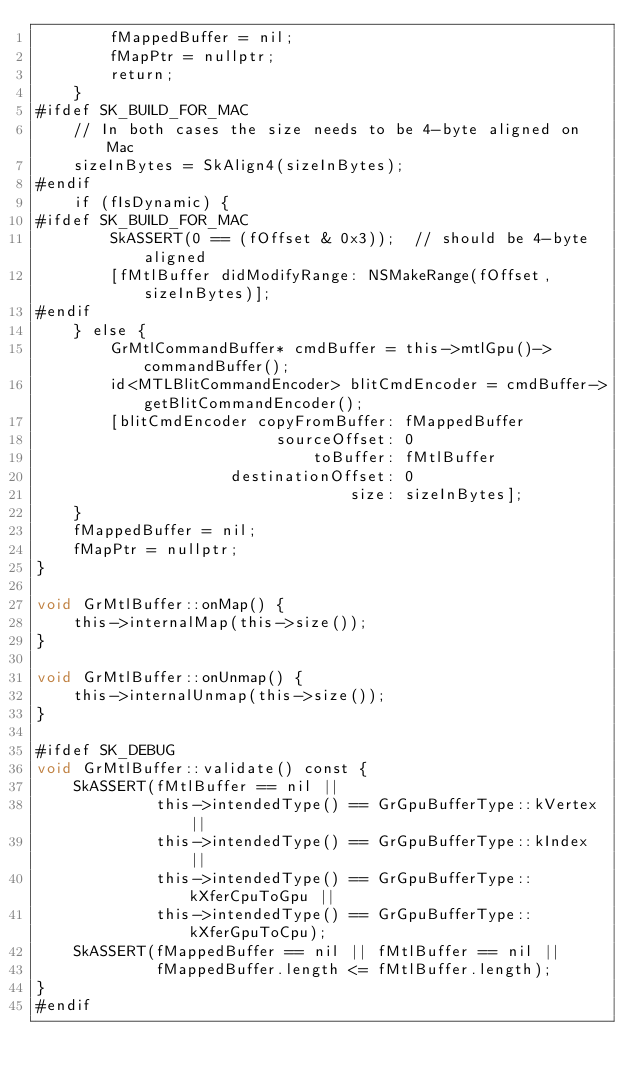<code> <loc_0><loc_0><loc_500><loc_500><_ObjectiveC_>        fMappedBuffer = nil;
        fMapPtr = nullptr;
        return;
    }
#ifdef SK_BUILD_FOR_MAC
    // In both cases the size needs to be 4-byte aligned on Mac
    sizeInBytes = SkAlign4(sizeInBytes);
#endif
    if (fIsDynamic) {
#ifdef SK_BUILD_FOR_MAC
        SkASSERT(0 == (fOffset & 0x3));  // should be 4-byte aligned
        [fMtlBuffer didModifyRange: NSMakeRange(fOffset, sizeInBytes)];
#endif
    } else {
        GrMtlCommandBuffer* cmdBuffer = this->mtlGpu()->commandBuffer();
        id<MTLBlitCommandEncoder> blitCmdEncoder = cmdBuffer->getBlitCommandEncoder();
        [blitCmdEncoder copyFromBuffer: fMappedBuffer
                          sourceOffset: 0
                              toBuffer: fMtlBuffer
                     destinationOffset: 0
                                  size: sizeInBytes];
    }
    fMappedBuffer = nil;
    fMapPtr = nullptr;
}

void GrMtlBuffer::onMap() {
    this->internalMap(this->size());
}

void GrMtlBuffer::onUnmap() {
    this->internalUnmap(this->size());
}

#ifdef SK_DEBUG
void GrMtlBuffer::validate() const {
    SkASSERT(fMtlBuffer == nil ||
             this->intendedType() == GrGpuBufferType::kVertex ||
             this->intendedType() == GrGpuBufferType::kIndex ||
             this->intendedType() == GrGpuBufferType::kXferCpuToGpu ||
             this->intendedType() == GrGpuBufferType::kXferGpuToCpu);
    SkASSERT(fMappedBuffer == nil || fMtlBuffer == nil ||
             fMappedBuffer.length <= fMtlBuffer.length);
}
#endif
</code> 